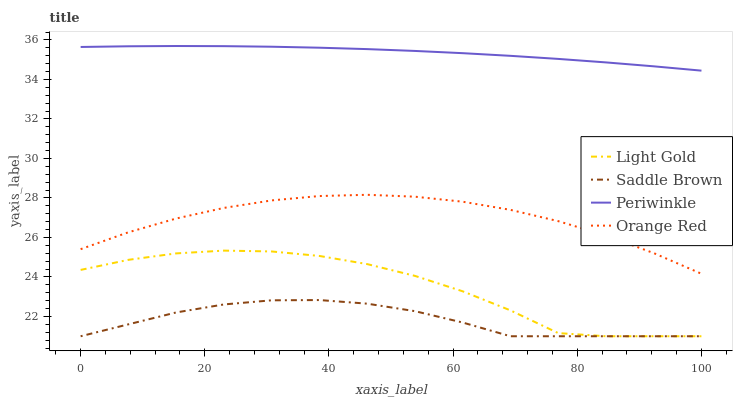Does Saddle Brown have the minimum area under the curve?
Answer yes or no. Yes. Does Periwinkle have the maximum area under the curve?
Answer yes or no. Yes. Does Light Gold have the minimum area under the curve?
Answer yes or no. No. Does Light Gold have the maximum area under the curve?
Answer yes or no. No. Is Periwinkle the smoothest?
Answer yes or no. Yes. Is Light Gold the roughest?
Answer yes or no. Yes. Is Saddle Brown the smoothest?
Answer yes or no. No. Is Saddle Brown the roughest?
Answer yes or no. No. Does Light Gold have the lowest value?
Answer yes or no. Yes. Does Orange Red have the lowest value?
Answer yes or no. No. Does Periwinkle have the highest value?
Answer yes or no. Yes. Does Light Gold have the highest value?
Answer yes or no. No. Is Orange Red less than Periwinkle?
Answer yes or no. Yes. Is Orange Red greater than Saddle Brown?
Answer yes or no. Yes. Does Saddle Brown intersect Light Gold?
Answer yes or no. Yes. Is Saddle Brown less than Light Gold?
Answer yes or no. No. Is Saddle Brown greater than Light Gold?
Answer yes or no. No. Does Orange Red intersect Periwinkle?
Answer yes or no. No. 